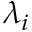Convert formula to latex. <formula><loc_0><loc_0><loc_500><loc_500>\lambda _ { i }</formula> 